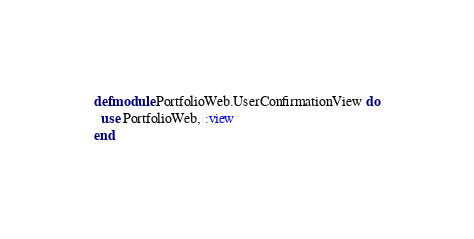<code> <loc_0><loc_0><loc_500><loc_500><_Elixir_>defmodule PortfolioWeb.UserConfirmationView do
  use PortfolioWeb, :view
end
</code> 